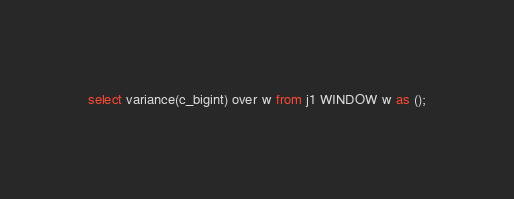<code> <loc_0><loc_0><loc_500><loc_500><_SQL_>select variance(c_bigint) over w from j1 WINDOW w as ();
</code> 